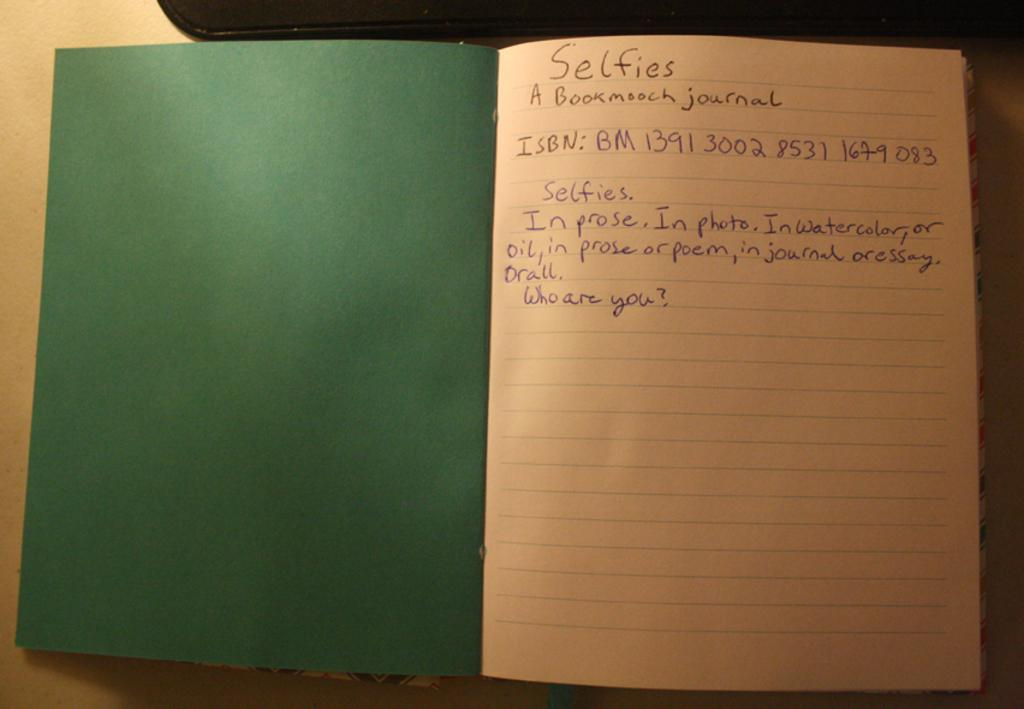<image>
Present a compact description of the photo's key features. An open green notebook with Selfies written on top. 